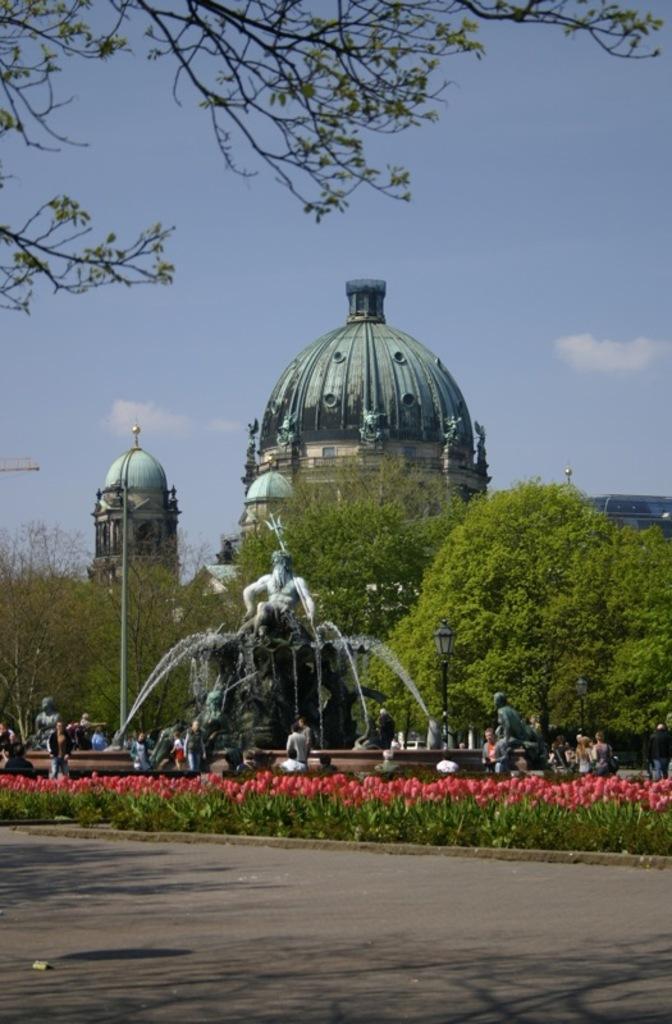How would you summarize this image in a sentence or two? In this image I can see the statues and the fountains. To the side of the statues I can see the group of people with different color dresses, light poles and the plants with flowers. I can see these flowers are in orange. In the background I can see many trees, buildings, clouds and the sky. 